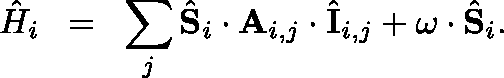Convert formula to latex. <formula><loc_0><loc_0><loc_500><loc_500>{ \hat { H } } _ { i } \, = \, \sum _ { j } \hat { S } _ { i } \cdot A _ { i , j } \cdot \hat { I } _ { i , j } + \omega \cdot \hat { S } _ { i } .</formula> 